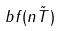Convert formula to latex. <formula><loc_0><loc_0><loc_500><loc_500>b f ( n \tilde { T } )</formula> 